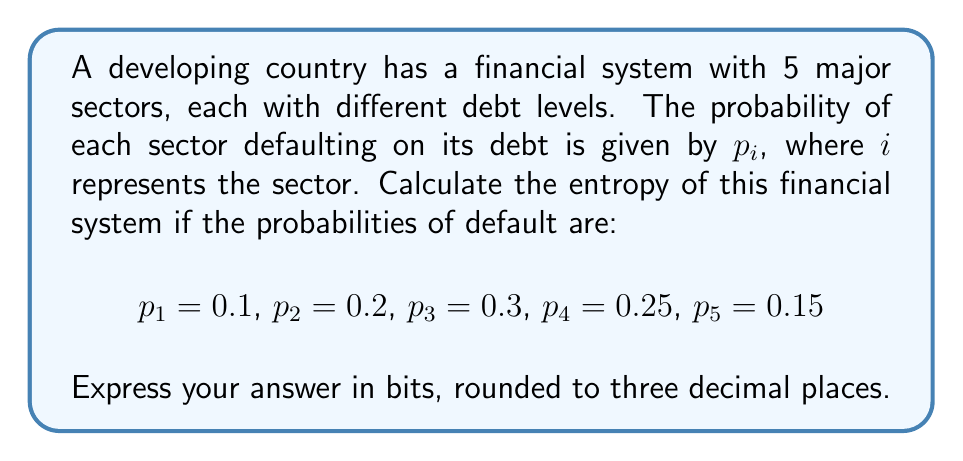Could you help me with this problem? To calculate the entropy of this financial system, we'll use the Shannon entropy formula:

$$S = -\sum_{i=1}^n p_i \log_2(p_i)$$

Where $S$ is the entropy, $p_i$ is the probability of each state, and $n$ is the number of states (in this case, sectors).

Let's calculate each term:

1) $-p_1 \log_2(p_1) = -0.1 \log_2(0.1) = 0.332$
2) $-p_2 \log_2(p_2) = -0.2 \log_2(0.2) = 0.464$
3) $-p_3 \log_2(p_3) = -0.3 \log_2(0.3) = 0.521$
4) $-p_4 \log_2(p_4) = -0.25 \log_2(0.25) = 0.5$
5) $-p_5 \log_2(p_5) = -0.15 \log_2(0.15) = 0.411$

Now, sum all these terms:

$$S = 0.332 + 0.464 + 0.521 + 0.5 + 0.411 = 2.228$$

Rounding to three decimal places, we get 2.228 bits.
Answer: 2.228 bits 